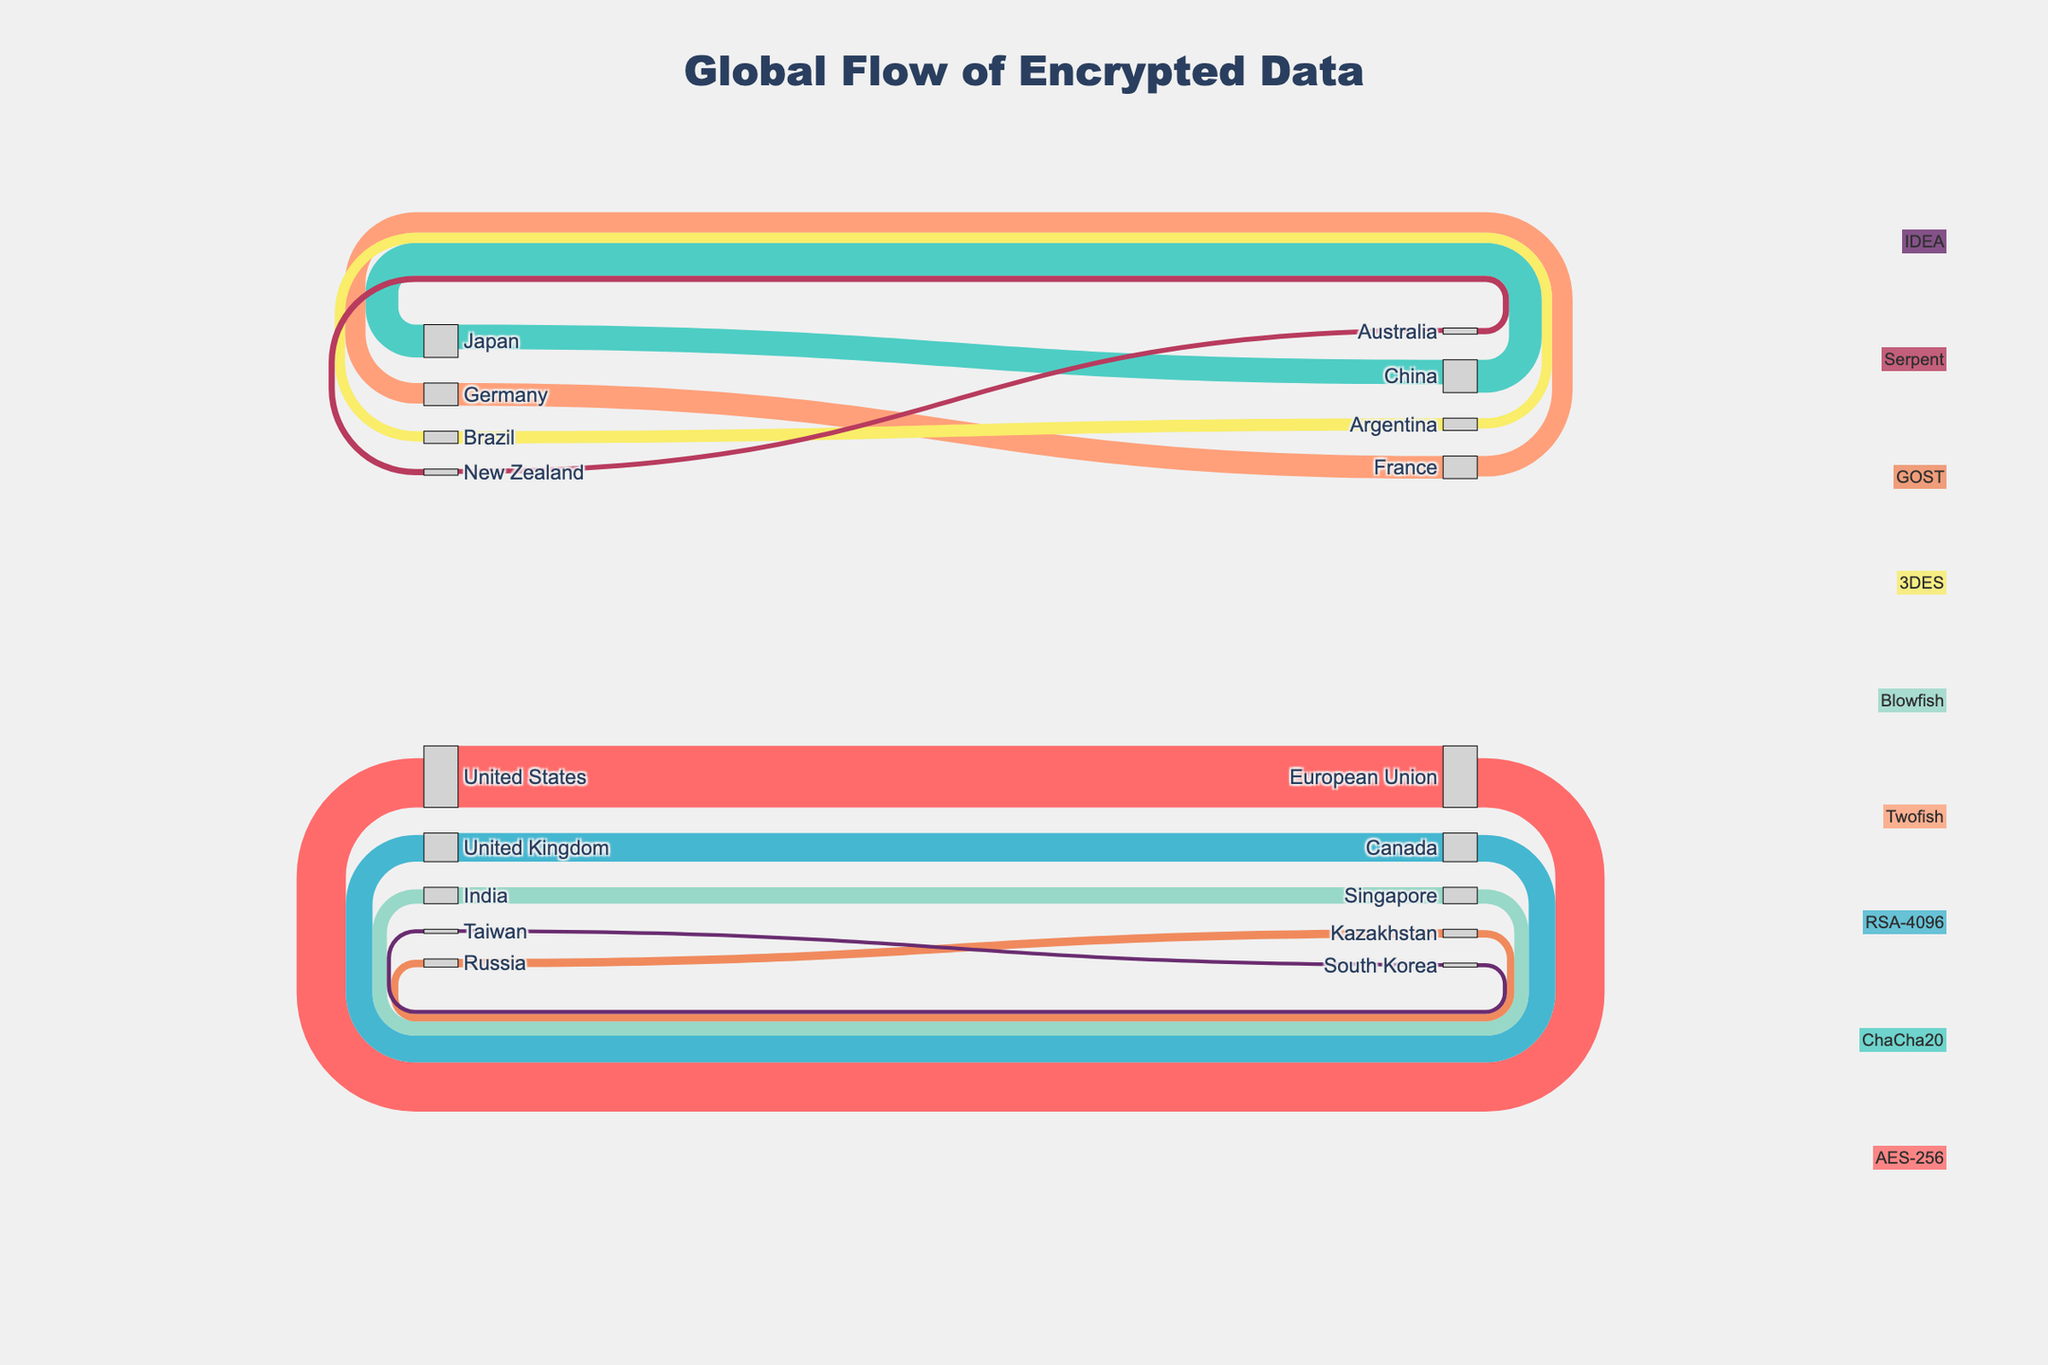What is the title of the Sankey Diagram? The title of the Sankey Diagram is placed at the top center of the figure and should be easily identifiable.
Answer: Global Flow of Encrypted Data How many types of encryption are shown in the diagram? The types of encryption are indicated by different colors and labels annotated on the side of the diagram. By counting these labeled annotations, we can determine the number of unique encryption types.
Answer: Nine Which encryption type has the highest data flow between two regions and what is the value? By examining the width of the flow lines and the corresponding values, we can identify the largest value associated with a specific encryption type. Look for the largest number next to a flow line.
Answer: AES-256, 1500 Between which countries is the Blowfish encryption type used, and what are the data flow values for each direction? Identify the color associated with Blowfish from the annotation and trace the flow lines of that color to see the source and target countries along with their corresponding values.
Answer: India-Singapore: 400, Singapore-India: 350 Compare the total data flow for ChaCha20 and RSA-4096 encryption types. Which one has a higher total flow and by how much? Sum the values for each encryption type. For ChaCha20: 800 (China to Japan) + 600 (Japan to China) = 1400. For RSA-4096: 700 (UK to Canada) + 650 (Canada to UK) = 1350. Then compare the totals.
Answer: ChaCha20, by 50 Which country pairs exchange data using the GOST encryption, and what are their respective values? Use the color map to identify the color representing GOST and trace those connections to see the country pairs and their values.
Answer: Russia-Kazakhstan: 200, Kazakhstan-Russia: 180 What is the smallest data flow value and which countries does it involve? Look at the flow lines with their values; the smallest visible value is the required one.
Answer: Taiwan to South Korea, 90 What’s the total amount of data transferred using the 3DES encryption type? Sum the values associated with 3DES: 300 (Brazil to Argentina) + 250 (Argentina to Brazil) = 550.
Answer: 550 Between which two countries is the data flow exchanged using the Twofish encryption and what are the respective values? Identify the flow lines with the color representing Twofish and note the corresponding countries and values.
Answer: Germany to France: 550, France to Germany: 500 How does the flow of encrypted data between the United States and the European Union compare to that between China and Japan? Sum the values for both directions between each pair of countries: US-EU: 1500 + 1200 = 2700, China-Japan: 800 + 600 = 1400. Compare the sums.
Answer: The flow between US and EU is higher by 1300 